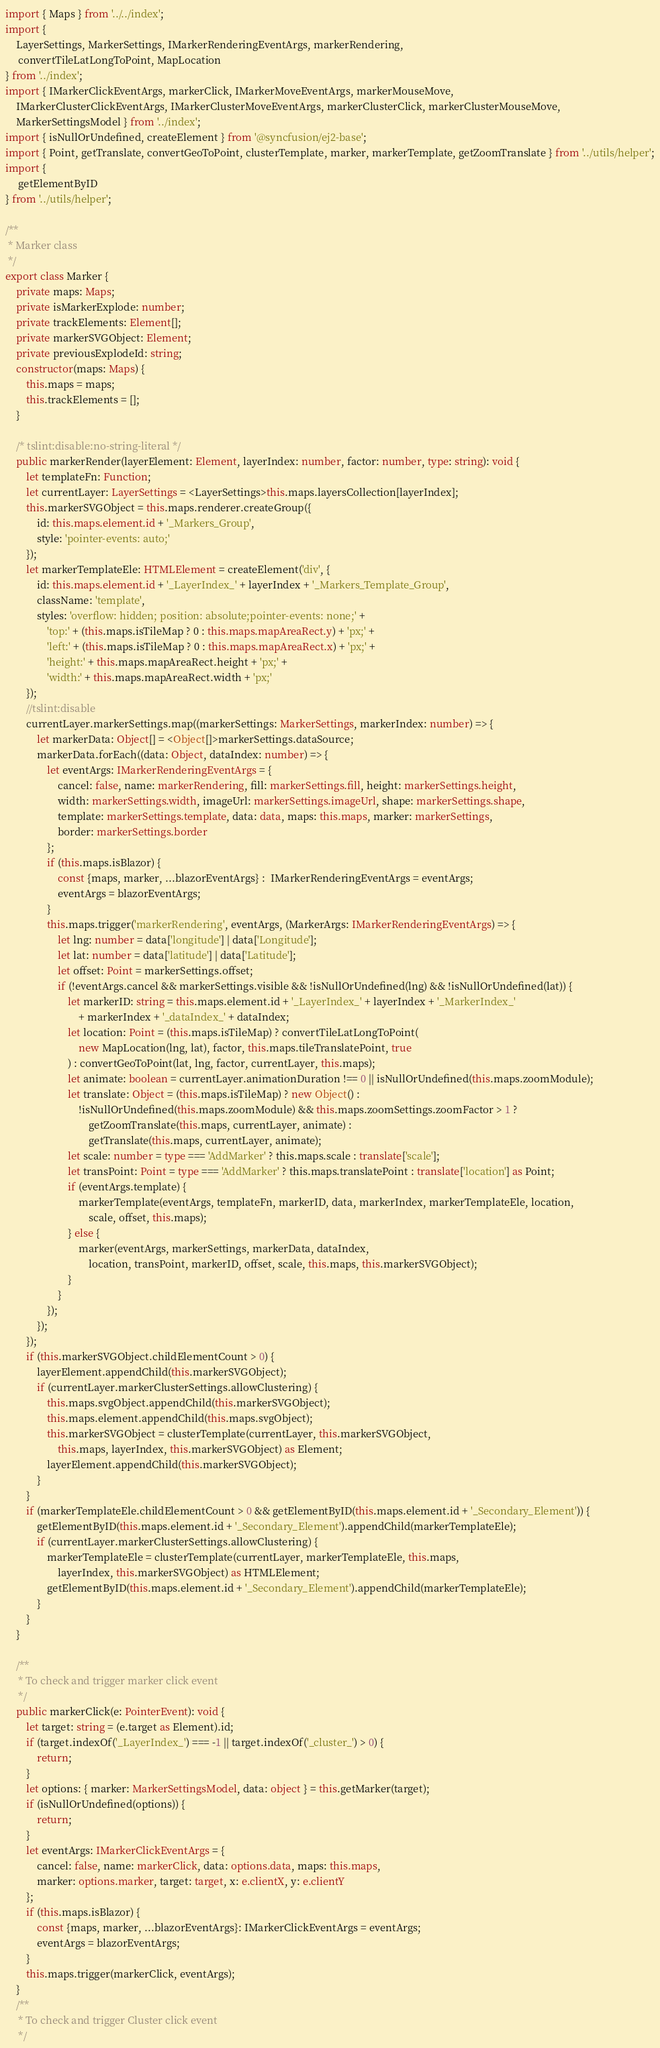<code> <loc_0><loc_0><loc_500><loc_500><_TypeScript_>import { Maps } from '../../index';
import {
    LayerSettings, MarkerSettings, IMarkerRenderingEventArgs, markerRendering,
     convertTileLatLongToPoint, MapLocation
} from '../index';
import { IMarkerClickEventArgs, markerClick, IMarkerMoveEventArgs, markerMouseMove,
    IMarkerClusterClickEventArgs, IMarkerClusterMoveEventArgs, markerClusterClick, markerClusterMouseMove,
    MarkerSettingsModel } from '../index';
import { isNullOrUndefined, createElement } from '@syncfusion/ej2-base';
import { Point, getTranslate, convertGeoToPoint, clusterTemplate, marker, markerTemplate, getZoomTranslate } from '../utils/helper';
import {
     getElementByID
} from '../utils/helper';

/**
 * Marker class
 */
export class Marker {
    private maps: Maps;
    private isMarkerExplode: number;
    private trackElements: Element[];
    private markerSVGObject: Element;
    private previousExplodeId: string;
    constructor(maps: Maps) {
        this.maps = maps;
        this.trackElements = [];
    }

    /* tslint:disable:no-string-literal */
    public markerRender(layerElement: Element, layerIndex: number, factor: number, type: string): void {
        let templateFn: Function;
        let currentLayer: LayerSettings = <LayerSettings>this.maps.layersCollection[layerIndex];
        this.markerSVGObject = this.maps.renderer.createGroup({
            id: this.maps.element.id + '_Markers_Group',
            style: 'pointer-events: auto;'
        });
        let markerTemplateEle: HTMLElement = createElement('div', {
            id: this.maps.element.id + '_LayerIndex_' + layerIndex + '_Markers_Template_Group',
            className: 'template',
            styles: 'overflow: hidden; position: absolute;pointer-events: none;' +
                'top:' + (this.maps.isTileMap ? 0 : this.maps.mapAreaRect.y) + 'px;' +
                'left:' + (this.maps.isTileMap ? 0 : this.maps.mapAreaRect.x) + 'px;' +
                'height:' + this.maps.mapAreaRect.height + 'px;' +
                'width:' + this.maps.mapAreaRect.width + 'px;'
        });
        //tslint:disable
        currentLayer.markerSettings.map((markerSettings: MarkerSettings, markerIndex: number) => {
            let markerData: Object[] = <Object[]>markerSettings.dataSource;
            markerData.forEach((data: Object, dataIndex: number) => {
                let eventArgs: IMarkerRenderingEventArgs = {
                    cancel: false, name: markerRendering, fill: markerSettings.fill, height: markerSettings.height,
                    width: markerSettings.width, imageUrl: markerSettings.imageUrl, shape: markerSettings.shape,
                    template: markerSettings.template, data: data, maps: this.maps, marker: markerSettings,
                    border: markerSettings.border
                };
                if (this.maps.isBlazor) {
                    const {maps, marker, ...blazorEventArgs} :  IMarkerRenderingEventArgs = eventArgs;
                    eventArgs = blazorEventArgs;
                }
                this.maps.trigger('markerRendering', eventArgs, (MarkerArgs: IMarkerRenderingEventArgs) => {
                    let lng: number = data['longitude'] | data['Longitude'];
                    let lat: number = data['latitude'] | data['Latitude'];
                    let offset: Point = markerSettings.offset;
                    if (!eventArgs.cancel && markerSettings.visible && !isNullOrUndefined(lng) && !isNullOrUndefined(lat)) {
                        let markerID: string = this.maps.element.id + '_LayerIndex_' + layerIndex + '_MarkerIndex_'
                            + markerIndex + '_dataIndex_' + dataIndex;
                        let location: Point = (this.maps.isTileMap) ? convertTileLatLongToPoint(
                            new MapLocation(lng, lat), factor, this.maps.tileTranslatePoint, true
                        ) : convertGeoToPoint(lat, lng, factor, currentLayer, this.maps);
                        let animate: boolean = currentLayer.animationDuration !== 0 || isNullOrUndefined(this.maps.zoomModule);
                        let translate: Object = (this.maps.isTileMap) ? new Object() :
                            !isNullOrUndefined(this.maps.zoomModule) && this.maps.zoomSettings.zoomFactor > 1 ?
                                getZoomTranslate(this.maps, currentLayer, animate) :
                                getTranslate(this.maps, currentLayer, animate);
                        let scale: number = type === 'AddMarker' ? this.maps.scale : translate['scale'];
                        let transPoint: Point = type === 'AddMarker' ? this.maps.translatePoint : translate['location'] as Point;
                        if (eventArgs.template) {
                            markerTemplate(eventArgs, templateFn, markerID, data, markerIndex, markerTemplateEle, location,
                                scale, offset, this.maps);
                        } else {
                            marker(eventArgs, markerSettings, markerData, dataIndex,
                                location, transPoint, markerID, offset, scale, this.maps, this.markerSVGObject);
                        }
                    }
                });
            });
        });
        if (this.markerSVGObject.childElementCount > 0) {
            layerElement.appendChild(this.markerSVGObject);
            if (currentLayer.markerClusterSettings.allowClustering) {
                this.maps.svgObject.appendChild(this.markerSVGObject);
                this.maps.element.appendChild(this.maps.svgObject);
                this.markerSVGObject = clusterTemplate(currentLayer, this.markerSVGObject,
                    this.maps, layerIndex, this.markerSVGObject) as Element;
                layerElement.appendChild(this.markerSVGObject);
            }
        }
        if (markerTemplateEle.childElementCount > 0 && getElementByID(this.maps.element.id + '_Secondary_Element')) {
            getElementByID(this.maps.element.id + '_Secondary_Element').appendChild(markerTemplateEle);
            if (currentLayer.markerClusterSettings.allowClustering) {
                markerTemplateEle = clusterTemplate(currentLayer, markerTemplateEle, this.maps,
                    layerIndex, this.markerSVGObject) as HTMLElement;
                getElementByID(this.maps.element.id + '_Secondary_Element').appendChild(markerTemplateEle);
            }
        }
    }

    /**
     * To check and trigger marker click event
     */
    public markerClick(e: PointerEvent): void {
        let target: string = (e.target as Element).id;
        if (target.indexOf('_LayerIndex_') === -1 || target.indexOf('_cluster_') > 0) {
            return;
        }
        let options: { marker: MarkerSettingsModel, data: object } = this.getMarker(target);
        if (isNullOrUndefined(options)) {
            return;
        }
        let eventArgs: IMarkerClickEventArgs = {
            cancel: false, name: markerClick, data: options.data, maps: this.maps,
            marker: options.marker, target: target, x: e.clientX, y: e.clientY
        };
        if (this.maps.isBlazor) {
            const {maps, marker, ...blazorEventArgs}: IMarkerClickEventArgs = eventArgs;
            eventArgs = blazorEventArgs;
        }
        this.maps.trigger(markerClick, eventArgs);
    }
    /**
     * To check and trigger Cluster click event
     */</code> 